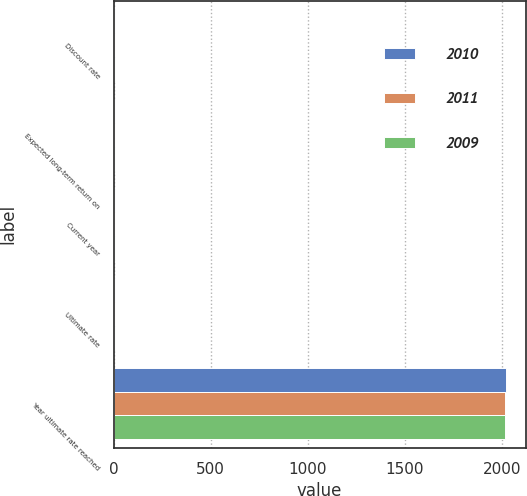Convert chart. <chart><loc_0><loc_0><loc_500><loc_500><stacked_bar_chart><ecel><fcel>Discount rate<fcel>Expected long-term return on<fcel>Current year<fcel>Ultimate rate<fcel>Year ultimate rate reached<nl><fcel>2010<fcel>5.5<fcel>7<fcel>9.75<fcel>5.5<fcel>2019<nl><fcel>2011<fcel>6<fcel>7<fcel>8.25<fcel>5.5<fcel>2016<nl><fcel>2009<fcel>6.25<fcel>7<fcel>8.75<fcel>5.5<fcel>2016<nl></chart> 